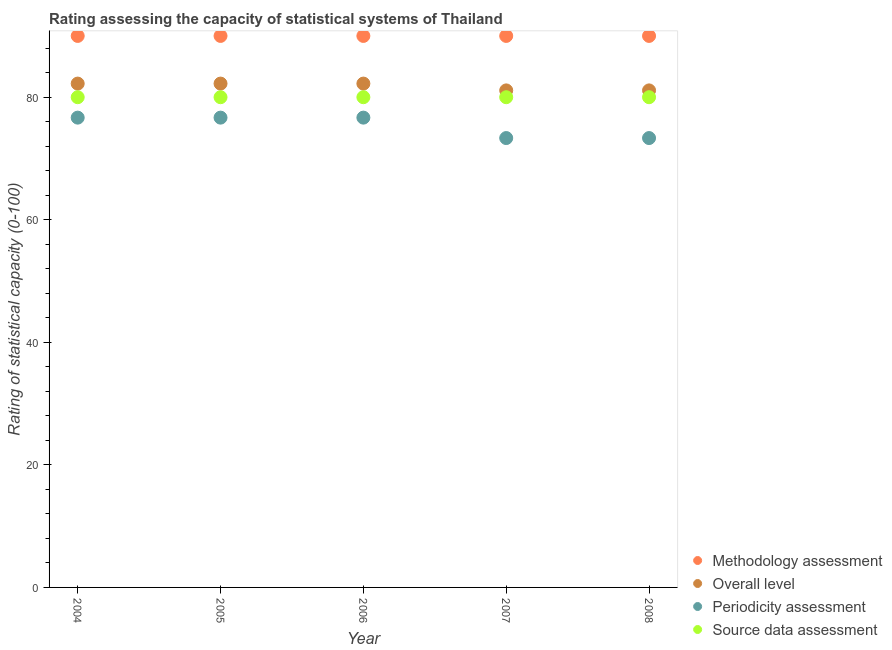How many different coloured dotlines are there?
Provide a short and direct response. 4. Is the number of dotlines equal to the number of legend labels?
Keep it short and to the point. Yes. What is the methodology assessment rating in 2005?
Ensure brevity in your answer.  90. Across all years, what is the maximum methodology assessment rating?
Give a very brief answer. 90. Across all years, what is the minimum overall level rating?
Keep it short and to the point. 81.11. In which year was the source data assessment rating minimum?
Keep it short and to the point. 2004. What is the total source data assessment rating in the graph?
Make the answer very short. 400. What is the difference between the overall level rating in 2005 and that in 2006?
Provide a short and direct response. 0. What is the difference between the periodicity assessment rating in 2004 and the overall level rating in 2008?
Provide a succinct answer. -4.44. What is the average periodicity assessment rating per year?
Keep it short and to the point. 75.33. In the year 2005, what is the difference between the periodicity assessment rating and source data assessment rating?
Your answer should be very brief. -3.33. What is the ratio of the methodology assessment rating in 2005 to that in 2006?
Your answer should be compact. 1. Is the source data assessment rating in 2005 less than that in 2007?
Give a very brief answer. No. What is the difference between the highest and the second highest overall level rating?
Provide a succinct answer. 0. What is the difference between the highest and the lowest overall level rating?
Provide a succinct answer. 1.11. In how many years, is the source data assessment rating greater than the average source data assessment rating taken over all years?
Ensure brevity in your answer.  0. Is it the case that in every year, the sum of the methodology assessment rating and periodicity assessment rating is greater than the sum of source data assessment rating and overall level rating?
Your answer should be compact. No. Is it the case that in every year, the sum of the methodology assessment rating and overall level rating is greater than the periodicity assessment rating?
Offer a terse response. Yes. Is the methodology assessment rating strictly less than the overall level rating over the years?
Give a very brief answer. No. Are the values on the major ticks of Y-axis written in scientific E-notation?
Ensure brevity in your answer.  No. Does the graph contain grids?
Ensure brevity in your answer.  No. How many legend labels are there?
Ensure brevity in your answer.  4. What is the title of the graph?
Provide a succinct answer. Rating assessing the capacity of statistical systems of Thailand. What is the label or title of the X-axis?
Your answer should be compact. Year. What is the label or title of the Y-axis?
Provide a succinct answer. Rating of statistical capacity (0-100). What is the Rating of statistical capacity (0-100) of Overall level in 2004?
Make the answer very short. 82.22. What is the Rating of statistical capacity (0-100) of Periodicity assessment in 2004?
Your response must be concise. 76.67. What is the Rating of statistical capacity (0-100) of Methodology assessment in 2005?
Provide a short and direct response. 90. What is the Rating of statistical capacity (0-100) in Overall level in 2005?
Ensure brevity in your answer.  82.22. What is the Rating of statistical capacity (0-100) of Periodicity assessment in 2005?
Make the answer very short. 76.67. What is the Rating of statistical capacity (0-100) of Source data assessment in 2005?
Keep it short and to the point. 80. What is the Rating of statistical capacity (0-100) in Methodology assessment in 2006?
Your response must be concise. 90. What is the Rating of statistical capacity (0-100) of Overall level in 2006?
Your response must be concise. 82.22. What is the Rating of statistical capacity (0-100) in Periodicity assessment in 2006?
Offer a very short reply. 76.67. What is the Rating of statistical capacity (0-100) in Source data assessment in 2006?
Ensure brevity in your answer.  80. What is the Rating of statistical capacity (0-100) in Overall level in 2007?
Your response must be concise. 81.11. What is the Rating of statistical capacity (0-100) in Periodicity assessment in 2007?
Your answer should be compact. 73.33. What is the Rating of statistical capacity (0-100) of Methodology assessment in 2008?
Provide a short and direct response. 90. What is the Rating of statistical capacity (0-100) in Overall level in 2008?
Provide a succinct answer. 81.11. What is the Rating of statistical capacity (0-100) in Periodicity assessment in 2008?
Provide a short and direct response. 73.33. What is the Rating of statistical capacity (0-100) of Source data assessment in 2008?
Your answer should be very brief. 80. Across all years, what is the maximum Rating of statistical capacity (0-100) of Overall level?
Make the answer very short. 82.22. Across all years, what is the maximum Rating of statistical capacity (0-100) in Periodicity assessment?
Offer a very short reply. 76.67. Across all years, what is the maximum Rating of statistical capacity (0-100) in Source data assessment?
Your answer should be compact. 80. Across all years, what is the minimum Rating of statistical capacity (0-100) in Methodology assessment?
Ensure brevity in your answer.  90. Across all years, what is the minimum Rating of statistical capacity (0-100) of Overall level?
Your answer should be very brief. 81.11. Across all years, what is the minimum Rating of statistical capacity (0-100) in Periodicity assessment?
Offer a very short reply. 73.33. What is the total Rating of statistical capacity (0-100) of Methodology assessment in the graph?
Provide a succinct answer. 450. What is the total Rating of statistical capacity (0-100) in Overall level in the graph?
Ensure brevity in your answer.  408.89. What is the total Rating of statistical capacity (0-100) in Periodicity assessment in the graph?
Keep it short and to the point. 376.67. What is the total Rating of statistical capacity (0-100) of Source data assessment in the graph?
Offer a terse response. 400. What is the difference between the Rating of statistical capacity (0-100) in Periodicity assessment in 2004 and that in 2005?
Offer a very short reply. 0. What is the difference between the Rating of statistical capacity (0-100) of Source data assessment in 2004 and that in 2005?
Your answer should be compact. 0. What is the difference between the Rating of statistical capacity (0-100) in Overall level in 2004 and that in 2006?
Offer a terse response. 0. What is the difference between the Rating of statistical capacity (0-100) of Periodicity assessment in 2004 and that in 2006?
Offer a terse response. 0. What is the difference between the Rating of statistical capacity (0-100) in Source data assessment in 2004 and that in 2006?
Ensure brevity in your answer.  0. What is the difference between the Rating of statistical capacity (0-100) in Overall level in 2004 and that in 2007?
Offer a very short reply. 1.11. What is the difference between the Rating of statistical capacity (0-100) of Periodicity assessment in 2004 and that in 2007?
Offer a very short reply. 3.33. What is the difference between the Rating of statistical capacity (0-100) in Source data assessment in 2004 and that in 2007?
Give a very brief answer. 0. What is the difference between the Rating of statistical capacity (0-100) of Overall level in 2004 and that in 2008?
Offer a terse response. 1.11. What is the difference between the Rating of statistical capacity (0-100) in Source data assessment in 2004 and that in 2008?
Your answer should be compact. 0. What is the difference between the Rating of statistical capacity (0-100) in Methodology assessment in 2005 and that in 2006?
Your answer should be compact. 0. What is the difference between the Rating of statistical capacity (0-100) of Overall level in 2005 and that in 2006?
Your response must be concise. 0. What is the difference between the Rating of statistical capacity (0-100) of Source data assessment in 2005 and that in 2006?
Keep it short and to the point. 0. What is the difference between the Rating of statistical capacity (0-100) of Methodology assessment in 2005 and that in 2007?
Provide a short and direct response. 0. What is the difference between the Rating of statistical capacity (0-100) in Methodology assessment in 2005 and that in 2008?
Keep it short and to the point. 0. What is the difference between the Rating of statistical capacity (0-100) in Overall level in 2005 and that in 2008?
Ensure brevity in your answer.  1.11. What is the difference between the Rating of statistical capacity (0-100) of Source data assessment in 2005 and that in 2008?
Ensure brevity in your answer.  0. What is the difference between the Rating of statistical capacity (0-100) of Overall level in 2006 and that in 2007?
Your response must be concise. 1.11. What is the difference between the Rating of statistical capacity (0-100) of Methodology assessment in 2006 and that in 2008?
Provide a short and direct response. 0. What is the difference between the Rating of statistical capacity (0-100) of Overall level in 2006 and that in 2008?
Ensure brevity in your answer.  1.11. What is the difference between the Rating of statistical capacity (0-100) of Periodicity assessment in 2006 and that in 2008?
Your answer should be very brief. 3.33. What is the difference between the Rating of statistical capacity (0-100) of Periodicity assessment in 2007 and that in 2008?
Provide a succinct answer. 0. What is the difference between the Rating of statistical capacity (0-100) in Methodology assessment in 2004 and the Rating of statistical capacity (0-100) in Overall level in 2005?
Your answer should be compact. 7.78. What is the difference between the Rating of statistical capacity (0-100) in Methodology assessment in 2004 and the Rating of statistical capacity (0-100) in Periodicity assessment in 2005?
Provide a short and direct response. 13.33. What is the difference between the Rating of statistical capacity (0-100) in Overall level in 2004 and the Rating of statistical capacity (0-100) in Periodicity assessment in 2005?
Your answer should be compact. 5.56. What is the difference between the Rating of statistical capacity (0-100) of Overall level in 2004 and the Rating of statistical capacity (0-100) of Source data assessment in 2005?
Give a very brief answer. 2.22. What is the difference between the Rating of statistical capacity (0-100) of Periodicity assessment in 2004 and the Rating of statistical capacity (0-100) of Source data assessment in 2005?
Provide a short and direct response. -3.33. What is the difference between the Rating of statistical capacity (0-100) of Methodology assessment in 2004 and the Rating of statistical capacity (0-100) of Overall level in 2006?
Keep it short and to the point. 7.78. What is the difference between the Rating of statistical capacity (0-100) in Methodology assessment in 2004 and the Rating of statistical capacity (0-100) in Periodicity assessment in 2006?
Your answer should be compact. 13.33. What is the difference between the Rating of statistical capacity (0-100) in Overall level in 2004 and the Rating of statistical capacity (0-100) in Periodicity assessment in 2006?
Offer a very short reply. 5.56. What is the difference between the Rating of statistical capacity (0-100) in Overall level in 2004 and the Rating of statistical capacity (0-100) in Source data assessment in 2006?
Offer a terse response. 2.22. What is the difference between the Rating of statistical capacity (0-100) of Periodicity assessment in 2004 and the Rating of statistical capacity (0-100) of Source data assessment in 2006?
Provide a succinct answer. -3.33. What is the difference between the Rating of statistical capacity (0-100) in Methodology assessment in 2004 and the Rating of statistical capacity (0-100) in Overall level in 2007?
Provide a succinct answer. 8.89. What is the difference between the Rating of statistical capacity (0-100) in Methodology assessment in 2004 and the Rating of statistical capacity (0-100) in Periodicity assessment in 2007?
Provide a succinct answer. 16.67. What is the difference between the Rating of statistical capacity (0-100) of Overall level in 2004 and the Rating of statistical capacity (0-100) of Periodicity assessment in 2007?
Make the answer very short. 8.89. What is the difference between the Rating of statistical capacity (0-100) of Overall level in 2004 and the Rating of statistical capacity (0-100) of Source data assessment in 2007?
Offer a very short reply. 2.22. What is the difference between the Rating of statistical capacity (0-100) in Methodology assessment in 2004 and the Rating of statistical capacity (0-100) in Overall level in 2008?
Your answer should be compact. 8.89. What is the difference between the Rating of statistical capacity (0-100) in Methodology assessment in 2004 and the Rating of statistical capacity (0-100) in Periodicity assessment in 2008?
Make the answer very short. 16.67. What is the difference between the Rating of statistical capacity (0-100) of Methodology assessment in 2004 and the Rating of statistical capacity (0-100) of Source data assessment in 2008?
Your answer should be compact. 10. What is the difference between the Rating of statistical capacity (0-100) in Overall level in 2004 and the Rating of statistical capacity (0-100) in Periodicity assessment in 2008?
Keep it short and to the point. 8.89. What is the difference between the Rating of statistical capacity (0-100) of Overall level in 2004 and the Rating of statistical capacity (0-100) of Source data assessment in 2008?
Make the answer very short. 2.22. What is the difference between the Rating of statistical capacity (0-100) in Methodology assessment in 2005 and the Rating of statistical capacity (0-100) in Overall level in 2006?
Give a very brief answer. 7.78. What is the difference between the Rating of statistical capacity (0-100) in Methodology assessment in 2005 and the Rating of statistical capacity (0-100) in Periodicity assessment in 2006?
Keep it short and to the point. 13.33. What is the difference between the Rating of statistical capacity (0-100) of Overall level in 2005 and the Rating of statistical capacity (0-100) of Periodicity assessment in 2006?
Offer a very short reply. 5.56. What is the difference between the Rating of statistical capacity (0-100) of Overall level in 2005 and the Rating of statistical capacity (0-100) of Source data assessment in 2006?
Offer a terse response. 2.22. What is the difference between the Rating of statistical capacity (0-100) of Methodology assessment in 2005 and the Rating of statistical capacity (0-100) of Overall level in 2007?
Offer a terse response. 8.89. What is the difference between the Rating of statistical capacity (0-100) of Methodology assessment in 2005 and the Rating of statistical capacity (0-100) of Periodicity assessment in 2007?
Your answer should be very brief. 16.67. What is the difference between the Rating of statistical capacity (0-100) in Methodology assessment in 2005 and the Rating of statistical capacity (0-100) in Source data assessment in 2007?
Ensure brevity in your answer.  10. What is the difference between the Rating of statistical capacity (0-100) in Overall level in 2005 and the Rating of statistical capacity (0-100) in Periodicity assessment in 2007?
Your response must be concise. 8.89. What is the difference between the Rating of statistical capacity (0-100) of Overall level in 2005 and the Rating of statistical capacity (0-100) of Source data assessment in 2007?
Keep it short and to the point. 2.22. What is the difference between the Rating of statistical capacity (0-100) of Methodology assessment in 2005 and the Rating of statistical capacity (0-100) of Overall level in 2008?
Your answer should be very brief. 8.89. What is the difference between the Rating of statistical capacity (0-100) of Methodology assessment in 2005 and the Rating of statistical capacity (0-100) of Periodicity assessment in 2008?
Your answer should be compact. 16.67. What is the difference between the Rating of statistical capacity (0-100) of Overall level in 2005 and the Rating of statistical capacity (0-100) of Periodicity assessment in 2008?
Keep it short and to the point. 8.89. What is the difference between the Rating of statistical capacity (0-100) in Overall level in 2005 and the Rating of statistical capacity (0-100) in Source data assessment in 2008?
Offer a very short reply. 2.22. What is the difference between the Rating of statistical capacity (0-100) of Methodology assessment in 2006 and the Rating of statistical capacity (0-100) of Overall level in 2007?
Offer a very short reply. 8.89. What is the difference between the Rating of statistical capacity (0-100) of Methodology assessment in 2006 and the Rating of statistical capacity (0-100) of Periodicity assessment in 2007?
Make the answer very short. 16.67. What is the difference between the Rating of statistical capacity (0-100) of Methodology assessment in 2006 and the Rating of statistical capacity (0-100) of Source data assessment in 2007?
Keep it short and to the point. 10. What is the difference between the Rating of statistical capacity (0-100) in Overall level in 2006 and the Rating of statistical capacity (0-100) in Periodicity assessment in 2007?
Offer a very short reply. 8.89. What is the difference between the Rating of statistical capacity (0-100) of Overall level in 2006 and the Rating of statistical capacity (0-100) of Source data assessment in 2007?
Make the answer very short. 2.22. What is the difference between the Rating of statistical capacity (0-100) of Methodology assessment in 2006 and the Rating of statistical capacity (0-100) of Overall level in 2008?
Ensure brevity in your answer.  8.89. What is the difference between the Rating of statistical capacity (0-100) of Methodology assessment in 2006 and the Rating of statistical capacity (0-100) of Periodicity assessment in 2008?
Provide a succinct answer. 16.67. What is the difference between the Rating of statistical capacity (0-100) of Methodology assessment in 2006 and the Rating of statistical capacity (0-100) of Source data assessment in 2008?
Provide a succinct answer. 10. What is the difference between the Rating of statistical capacity (0-100) of Overall level in 2006 and the Rating of statistical capacity (0-100) of Periodicity assessment in 2008?
Your answer should be compact. 8.89. What is the difference between the Rating of statistical capacity (0-100) in Overall level in 2006 and the Rating of statistical capacity (0-100) in Source data assessment in 2008?
Offer a terse response. 2.22. What is the difference between the Rating of statistical capacity (0-100) in Periodicity assessment in 2006 and the Rating of statistical capacity (0-100) in Source data assessment in 2008?
Your answer should be very brief. -3.33. What is the difference between the Rating of statistical capacity (0-100) in Methodology assessment in 2007 and the Rating of statistical capacity (0-100) in Overall level in 2008?
Your response must be concise. 8.89. What is the difference between the Rating of statistical capacity (0-100) in Methodology assessment in 2007 and the Rating of statistical capacity (0-100) in Periodicity assessment in 2008?
Provide a succinct answer. 16.67. What is the difference between the Rating of statistical capacity (0-100) of Overall level in 2007 and the Rating of statistical capacity (0-100) of Periodicity assessment in 2008?
Your answer should be very brief. 7.78. What is the difference between the Rating of statistical capacity (0-100) of Overall level in 2007 and the Rating of statistical capacity (0-100) of Source data assessment in 2008?
Your answer should be very brief. 1.11. What is the difference between the Rating of statistical capacity (0-100) of Periodicity assessment in 2007 and the Rating of statistical capacity (0-100) of Source data assessment in 2008?
Ensure brevity in your answer.  -6.67. What is the average Rating of statistical capacity (0-100) of Methodology assessment per year?
Your response must be concise. 90. What is the average Rating of statistical capacity (0-100) of Overall level per year?
Provide a short and direct response. 81.78. What is the average Rating of statistical capacity (0-100) of Periodicity assessment per year?
Keep it short and to the point. 75.33. In the year 2004, what is the difference between the Rating of statistical capacity (0-100) in Methodology assessment and Rating of statistical capacity (0-100) in Overall level?
Make the answer very short. 7.78. In the year 2004, what is the difference between the Rating of statistical capacity (0-100) of Methodology assessment and Rating of statistical capacity (0-100) of Periodicity assessment?
Provide a succinct answer. 13.33. In the year 2004, what is the difference between the Rating of statistical capacity (0-100) in Methodology assessment and Rating of statistical capacity (0-100) in Source data assessment?
Your answer should be compact. 10. In the year 2004, what is the difference between the Rating of statistical capacity (0-100) of Overall level and Rating of statistical capacity (0-100) of Periodicity assessment?
Your answer should be very brief. 5.56. In the year 2004, what is the difference between the Rating of statistical capacity (0-100) in Overall level and Rating of statistical capacity (0-100) in Source data assessment?
Keep it short and to the point. 2.22. In the year 2004, what is the difference between the Rating of statistical capacity (0-100) in Periodicity assessment and Rating of statistical capacity (0-100) in Source data assessment?
Ensure brevity in your answer.  -3.33. In the year 2005, what is the difference between the Rating of statistical capacity (0-100) in Methodology assessment and Rating of statistical capacity (0-100) in Overall level?
Offer a terse response. 7.78. In the year 2005, what is the difference between the Rating of statistical capacity (0-100) of Methodology assessment and Rating of statistical capacity (0-100) of Periodicity assessment?
Provide a succinct answer. 13.33. In the year 2005, what is the difference between the Rating of statistical capacity (0-100) in Overall level and Rating of statistical capacity (0-100) in Periodicity assessment?
Ensure brevity in your answer.  5.56. In the year 2005, what is the difference between the Rating of statistical capacity (0-100) in Overall level and Rating of statistical capacity (0-100) in Source data assessment?
Make the answer very short. 2.22. In the year 2005, what is the difference between the Rating of statistical capacity (0-100) in Periodicity assessment and Rating of statistical capacity (0-100) in Source data assessment?
Your answer should be very brief. -3.33. In the year 2006, what is the difference between the Rating of statistical capacity (0-100) of Methodology assessment and Rating of statistical capacity (0-100) of Overall level?
Give a very brief answer. 7.78. In the year 2006, what is the difference between the Rating of statistical capacity (0-100) in Methodology assessment and Rating of statistical capacity (0-100) in Periodicity assessment?
Make the answer very short. 13.33. In the year 2006, what is the difference between the Rating of statistical capacity (0-100) of Methodology assessment and Rating of statistical capacity (0-100) of Source data assessment?
Offer a terse response. 10. In the year 2006, what is the difference between the Rating of statistical capacity (0-100) of Overall level and Rating of statistical capacity (0-100) of Periodicity assessment?
Give a very brief answer. 5.56. In the year 2006, what is the difference between the Rating of statistical capacity (0-100) of Overall level and Rating of statistical capacity (0-100) of Source data assessment?
Offer a very short reply. 2.22. In the year 2006, what is the difference between the Rating of statistical capacity (0-100) of Periodicity assessment and Rating of statistical capacity (0-100) of Source data assessment?
Your answer should be compact. -3.33. In the year 2007, what is the difference between the Rating of statistical capacity (0-100) of Methodology assessment and Rating of statistical capacity (0-100) of Overall level?
Give a very brief answer. 8.89. In the year 2007, what is the difference between the Rating of statistical capacity (0-100) of Methodology assessment and Rating of statistical capacity (0-100) of Periodicity assessment?
Make the answer very short. 16.67. In the year 2007, what is the difference between the Rating of statistical capacity (0-100) of Overall level and Rating of statistical capacity (0-100) of Periodicity assessment?
Provide a succinct answer. 7.78. In the year 2007, what is the difference between the Rating of statistical capacity (0-100) of Periodicity assessment and Rating of statistical capacity (0-100) of Source data assessment?
Make the answer very short. -6.67. In the year 2008, what is the difference between the Rating of statistical capacity (0-100) in Methodology assessment and Rating of statistical capacity (0-100) in Overall level?
Keep it short and to the point. 8.89. In the year 2008, what is the difference between the Rating of statistical capacity (0-100) in Methodology assessment and Rating of statistical capacity (0-100) in Periodicity assessment?
Give a very brief answer. 16.67. In the year 2008, what is the difference between the Rating of statistical capacity (0-100) of Methodology assessment and Rating of statistical capacity (0-100) of Source data assessment?
Provide a short and direct response. 10. In the year 2008, what is the difference between the Rating of statistical capacity (0-100) of Overall level and Rating of statistical capacity (0-100) of Periodicity assessment?
Your answer should be compact. 7.78. In the year 2008, what is the difference between the Rating of statistical capacity (0-100) in Periodicity assessment and Rating of statistical capacity (0-100) in Source data assessment?
Give a very brief answer. -6.67. What is the ratio of the Rating of statistical capacity (0-100) of Periodicity assessment in 2004 to that in 2005?
Your answer should be compact. 1. What is the ratio of the Rating of statistical capacity (0-100) of Methodology assessment in 2004 to that in 2006?
Offer a very short reply. 1. What is the ratio of the Rating of statistical capacity (0-100) in Periodicity assessment in 2004 to that in 2006?
Give a very brief answer. 1. What is the ratio of the Rating of statistical capacity (0-100) in Source data assessment in 2004 to that in 2006?
Your response must be concise. 1. What is the ratio of the Rating of statistical capacity (0-100) in Overall level in 2004 to that in 2007?
Ensure brevity in your answer.  1.01. What is the ratio of the Rating of statistical capacity (0-100) in Periodicity assessment in 2004 to that in 2007?
Provide a succinct answer. 1.05. What is the ratio of the Rating of statistical capacity (0-100) in Methodology assessment in 2004 to that in 2008?
Offer a terse response. 1. What is the ratio of the Rating of statistical capacity (0-100) in Overall level in 2004 to that in 2008?
Give a very brief answer. 1.01. What is the ratio of the Rating of statistical capacity (0-100) in Periodicity assessment in 2004 to that in 2008?
Your answer should be compact. 1.05. What is the ratio of the Rating of statistical capacity (0-100) in Source data assessment in 2004 to that in 2008?
Keep it short and to the point. 1. What is the ratio of the Rating of statistical capacity (0-100) in Overall level in 2005 to that in 2007?
Provide a succinct answer. 1.01. What is the ratio of the Rating of statistical capacity (0-100) of Periodicity assessment in 2005 to that in 2007?
Ensure brevity in your answer.  1.05. What is the ratio of the Rating of statistical capacity (0-100) of Source data assessment in 2005 to that in 2007?
Keep it short and to the point. 1. What is the ratio of the Rating of statistical capacity (0-100) of Overall level in 2005 to that in 2008?
Ensure brevity in your answer.  1.01. What is the ratio of the Rating of statistical capacity (0-100) of Periodicity assessment in 2005 to that in 2008?
Your answer should be very brief. 1.05. What is the ratio of the Rating of statistical capacity (0-100) in Source data assessment in 2005 to that in 2008?
Give a very brief answer. 1. What is the ratio of the Rating of statistical capacity (0-100) of Methodology assessment in 2006 to that in 2007?
Keep it short and to the point. 1. What is the ratio of the Rating of statistical capacity (0-100) in Overall level in 2006 to that in 2007?
Your answer should be compact. 1.01. What is the ratio of the Rating of statistical capacity (0-100) of Periodicity assessment in 2006 to that in 2007?
Give a very brief answer. 1.05. What is the ratio of the Rating of statistical capacity (0-100) in Methodology assessment in 2006 to that in 2008?
Keep it short and to the point. 1. What is the ratio of the Rating of statistical capacity (0-100) of Overall level in 2006 to that in 2008?
Give a very brief answer. 1.01. What is the ratio of the Rating of statistical capacity (0-100) of Periodicity assessment in 2006 to that in 2008?
Provide a succinct answer. 1.05. What is the ratio of the Rating of statistical capacity (0-100) of Source data assessment in 2006 to that in 2008?
Provide a short and direct response. 1. What is the ratio of the Rating of statistical capacity (0-100) in Methodology assessment in 2007 to that in 2008?
Keep it short and to the point. 1. What is the ratio of the Rating of statistical capacity (0-100) in Overall level in 2007 to that in 2008?
Your answer should be compact. 1. What is the ratio of the Rating of statistical capacity (0-100) in Periodicity assessment in 2007 to that in 2008?
Keep it short and to the point. 1. What is the difference between the highest and the lowest Rating of statistical capacity (0-100) of Source data assessment?
Offer a terse response. 0. 